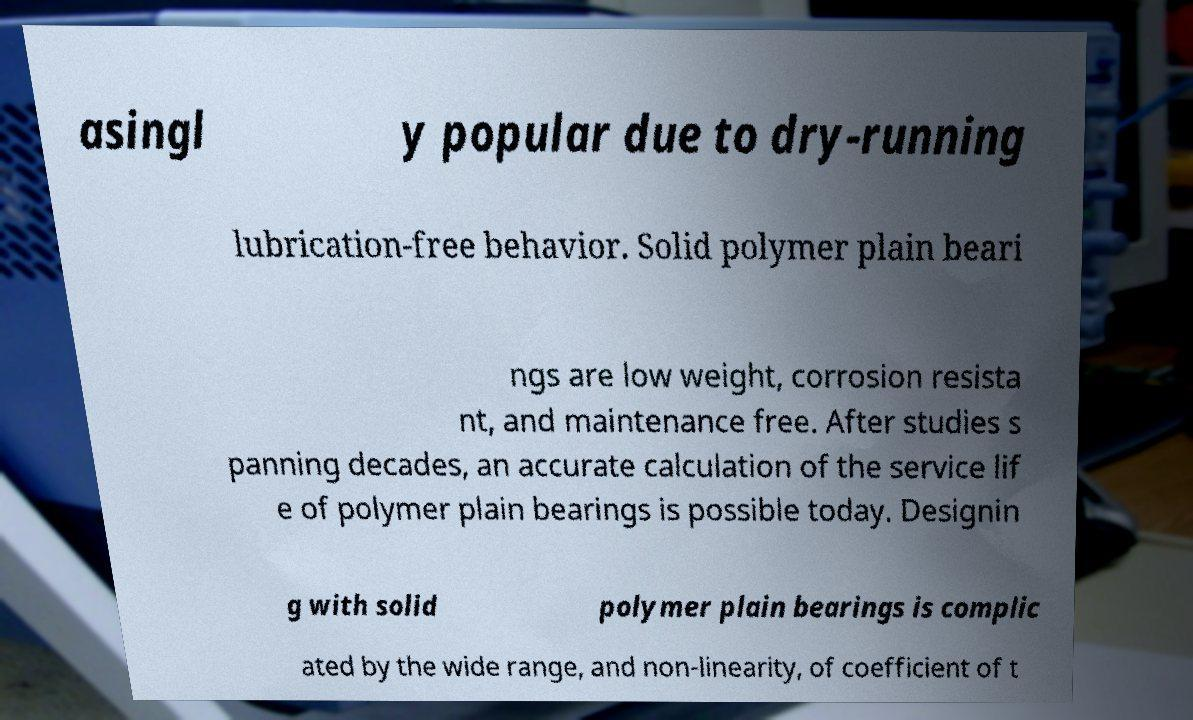Please identify and transcribe the text found in this image. asingl y popular due to dry-running lubrication-free behavior. Solid polymer plain beari ngs are low weight, corrosion resista nt, and maintenance free. After studies s panning decades, an accurate calculation of the service lif e of polymer plain bearings is possible today. Designin g with solid polymer plain bearings is complic ated by the wide range, and non-linearity, of coefficient of t 